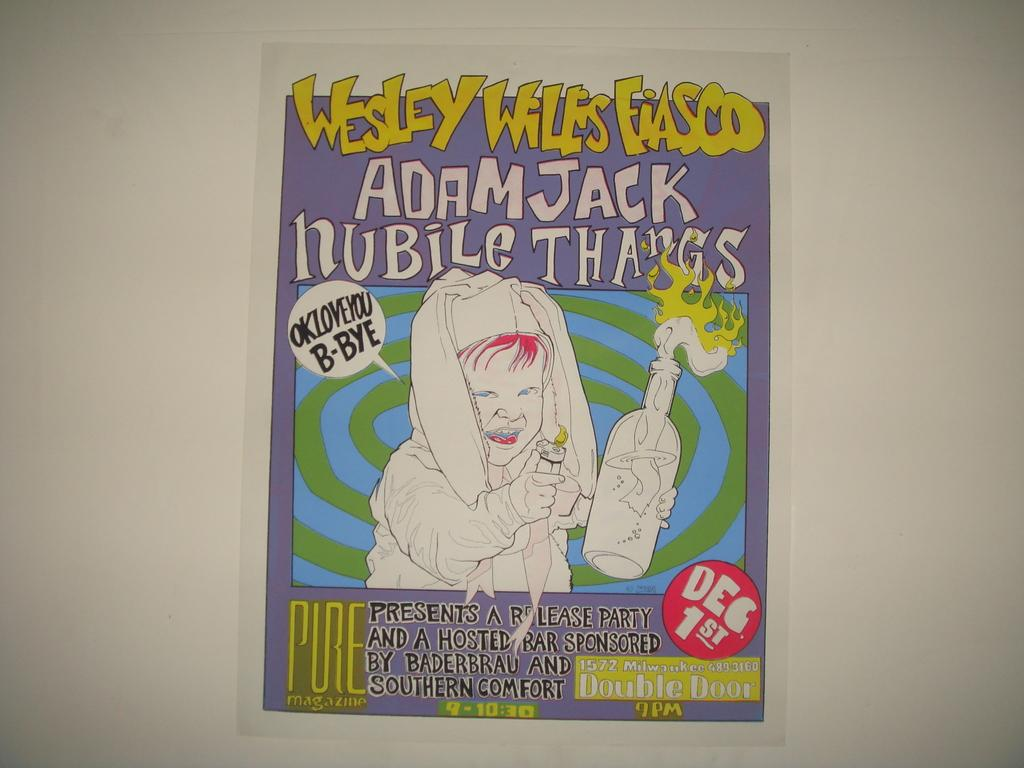<image>
Describe the image concisely. An advertisement for Adam Jack Nubile Thangs on December 1. 